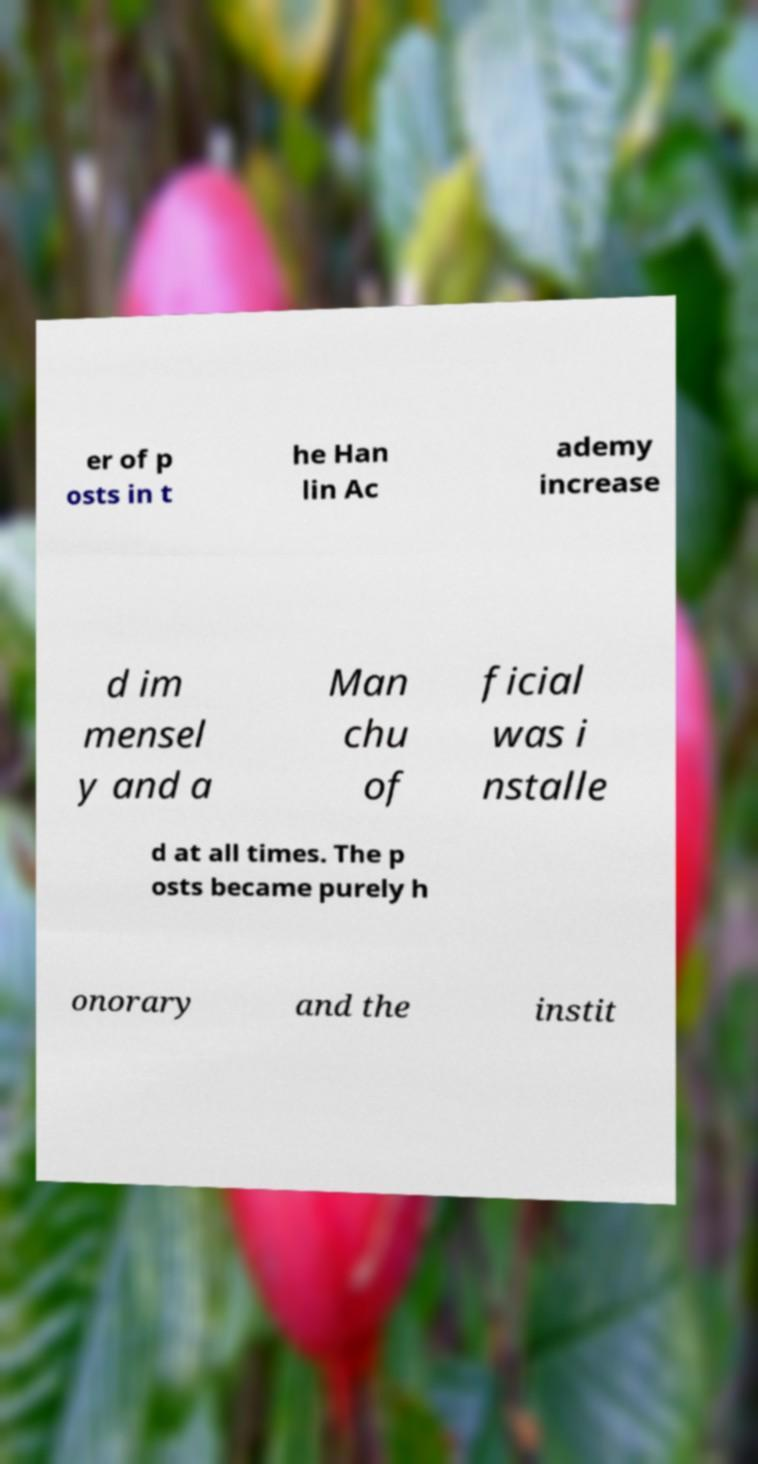Can you accurately transcribe the text from the provided image for me? er of p osts in t he Han lin Ac ademy increase d im mensel y and a Man chu of ficial was i nstalle d at all times. The p osts became purely h onorary and the instit 